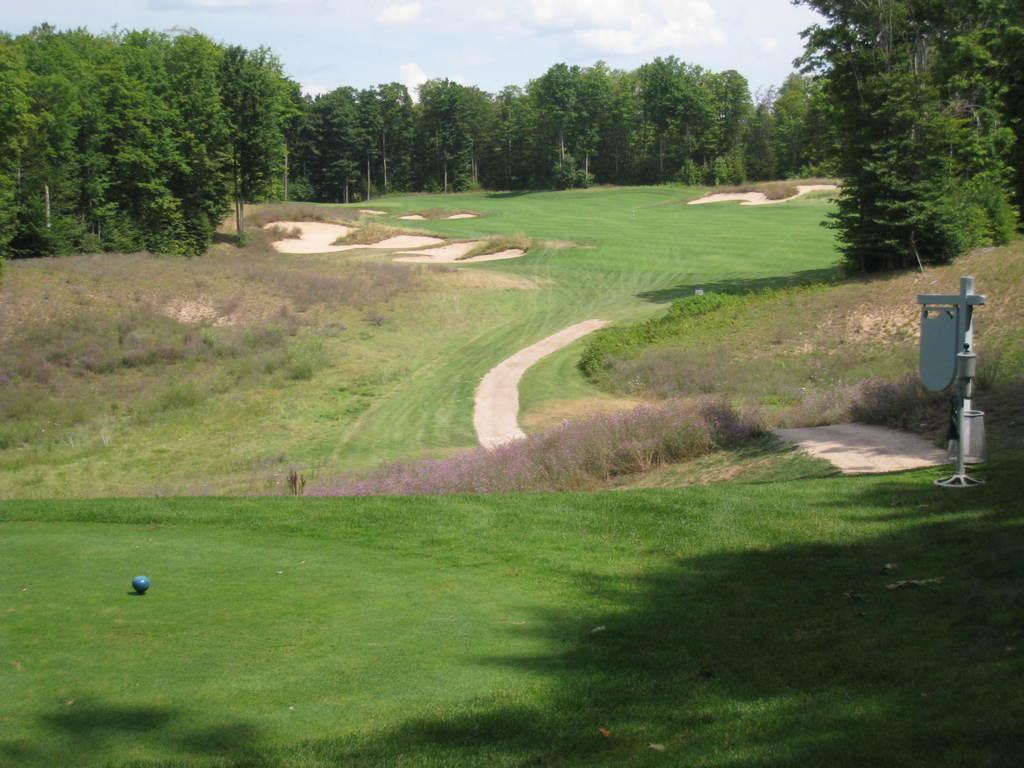What type of vegetation is present in the image? There are trees in the image. What structure can be seen in the image? There is a stand in the image. What type of container is visible in the image? There is a bin in the image. What type of ground surface is at the bottom of the image? There is grass at the bottom of the image. What object is on the ground in the image? There is a ball on the ground in the image. What type of science experiment is being conducted in the image? There is no indication of a science experiment being conducted in the image. Can you see a nest in the trees in the image? There is no nest visible in the trees in the image. 